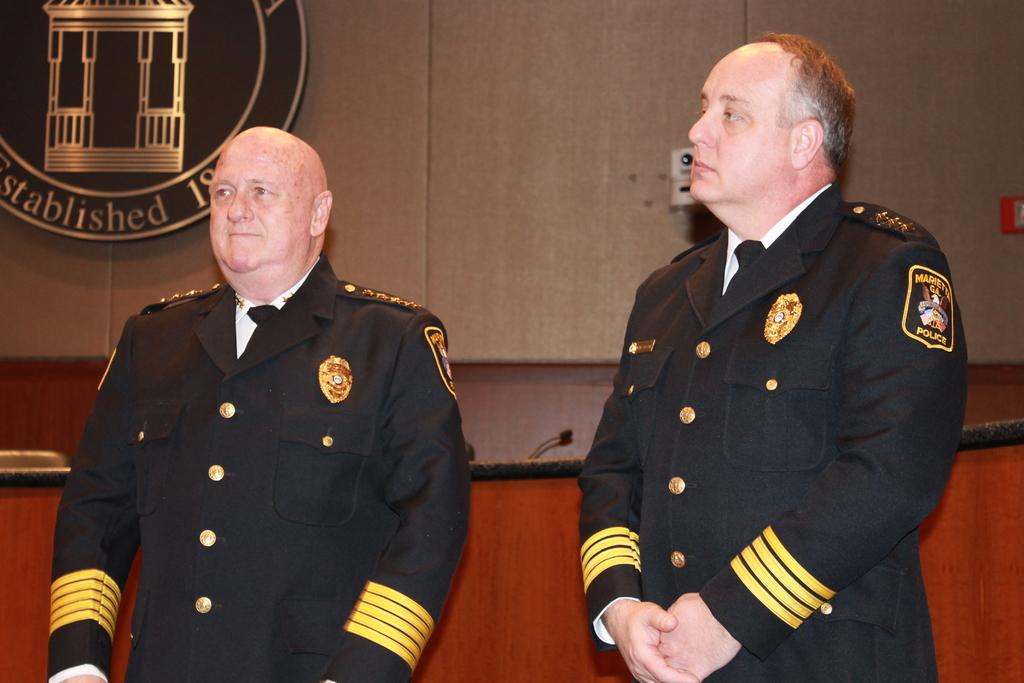How many people are in the image? There are two men standing in the image. What are the men wearing? The men are wearing clothes. What object can be seen in the image that is typically used for amplifying sound? There is a microphone in the image. What type of structure is visible in the image? There is a wall in the image. What can be seen on the wall in the image? There is a logo in the image. Can you tell me how many ducks are swimming in the mine in the image? There are no ducks or mines present in the image. What type of country is depicted in the image? The image does not depict a country; it features two men, a microphone, a wall, and a logo. 